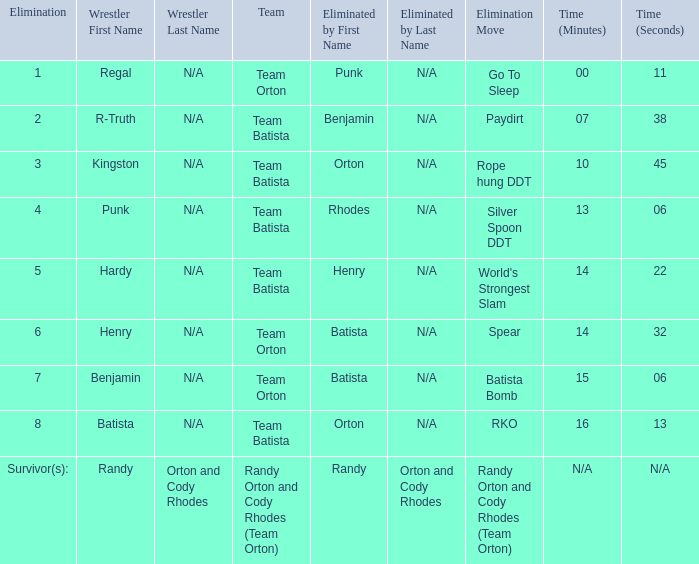Which Elimination move is listed against Team Orton, Eliminated by Batista against Elimination number 7? Batista Bomb. 